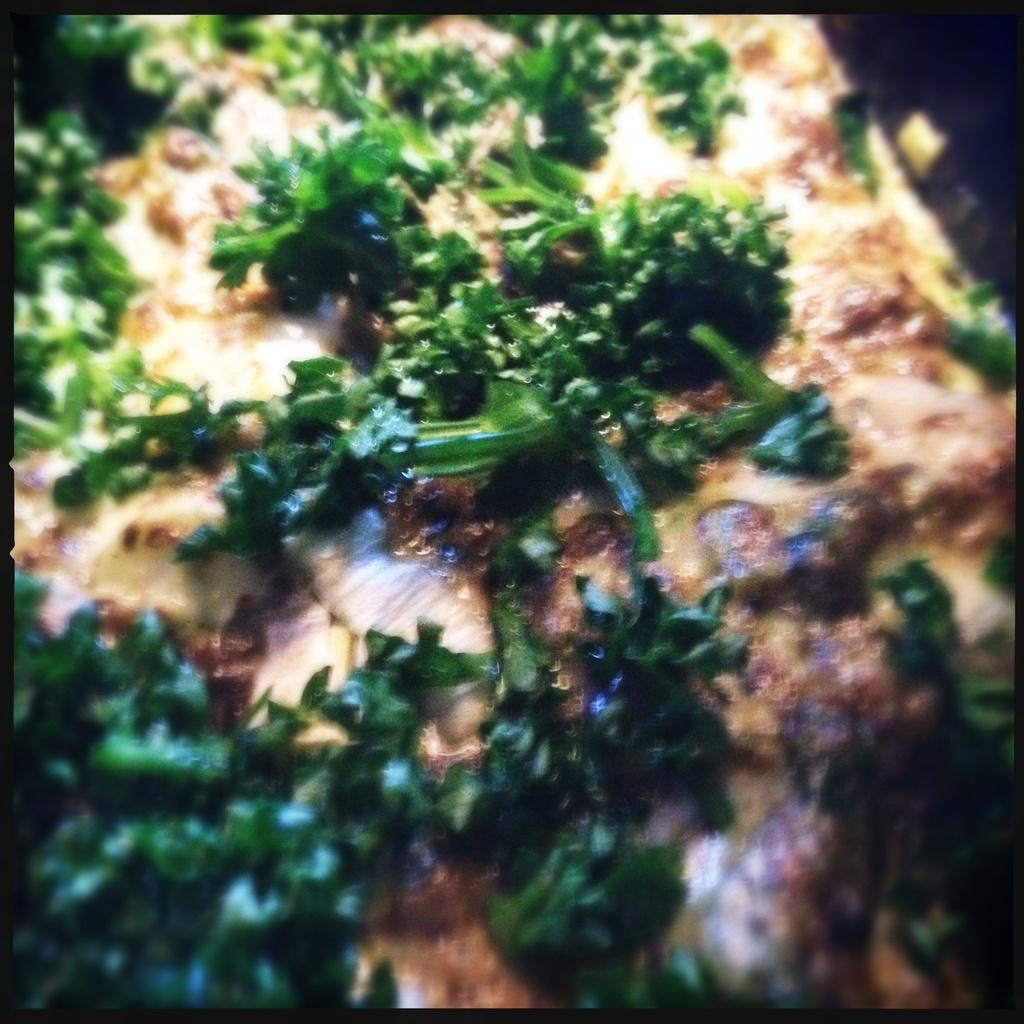What type of food is shown in the image? There is pizza in the image. What other food item can be seen on the tray? There is a green color vegetable on the tray. How are the pizza and vegetable arranged in the image? The pizza and vegetable are on a tray. Which actor is performing a trick with their nerves in the image? There is no actor, trick, or mention of nerves in the image. 